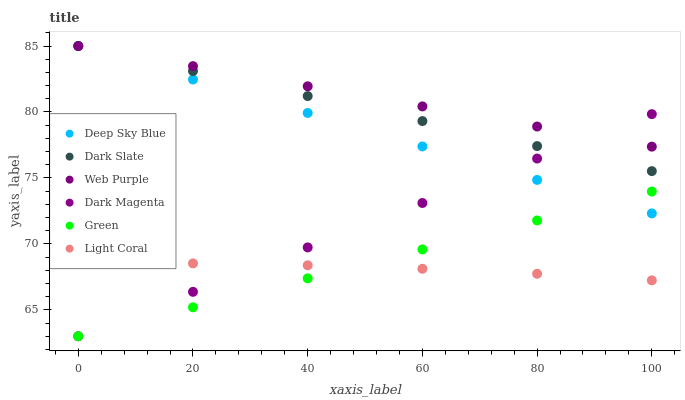Does Light Coral have the minimum area under the curve?
Answer yes or no. Yes. Does Web Purple have the maximum area under the curve?
Answer yes or no. Yes. Does Dark Slate have the minimum area under the curve?
Answer yes or no. No. Does Dark Slate have the maximum area under the curve?
Answer yes or no. No. Is Green the smoothest?
Answer yes or no. Yes. Is Light Coral the roughest?
Answer yes or no. Yes. Is Dark Slate the smoothest?
Answer yes or no. No. Is Dark Slate the roughest?
Answer yes or no. No. Does Dark Magenta have the lowest value?
Answer yes or no. Yes. Does Light Coral have the lowest value?
Answer yes or no. No. Does Deep Sky Blue have the highest value?
Answer yes or no. Yes. Does Light Coral have the highest value?
Answer yes or no. No. Is Light Coral less than Dark Slate?
Answer yes or no. Yes. Is Web Purple greater than Light Coral?
Answer yes or no. Yes. Does Web Purple intersect Deep Sky Blue?
Answer yes or no. Yes. Is Web Purple less than Deep Sky Blue?
Answer yes or no. No. Is Web Purple greater than Deep Sky Blue?
Answer yes or no. No. Does Light Coral intersect Dark Slate?
Answer yes or no. No. 